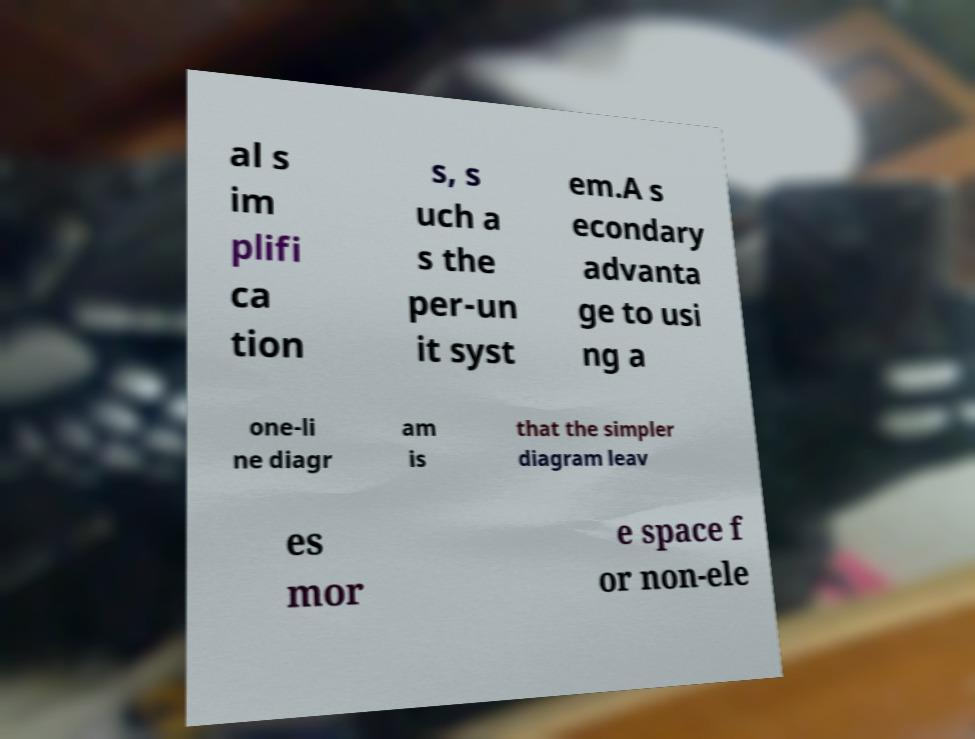I need the written content from this picture converted into text. Can you do that? al s im plifi ca tion s, s uch a s the per-un it syst em.A s econdary advanta ge to usi ng a one-li ne diagr am is that the simpler diagram leav es mor e space f or non-ele 